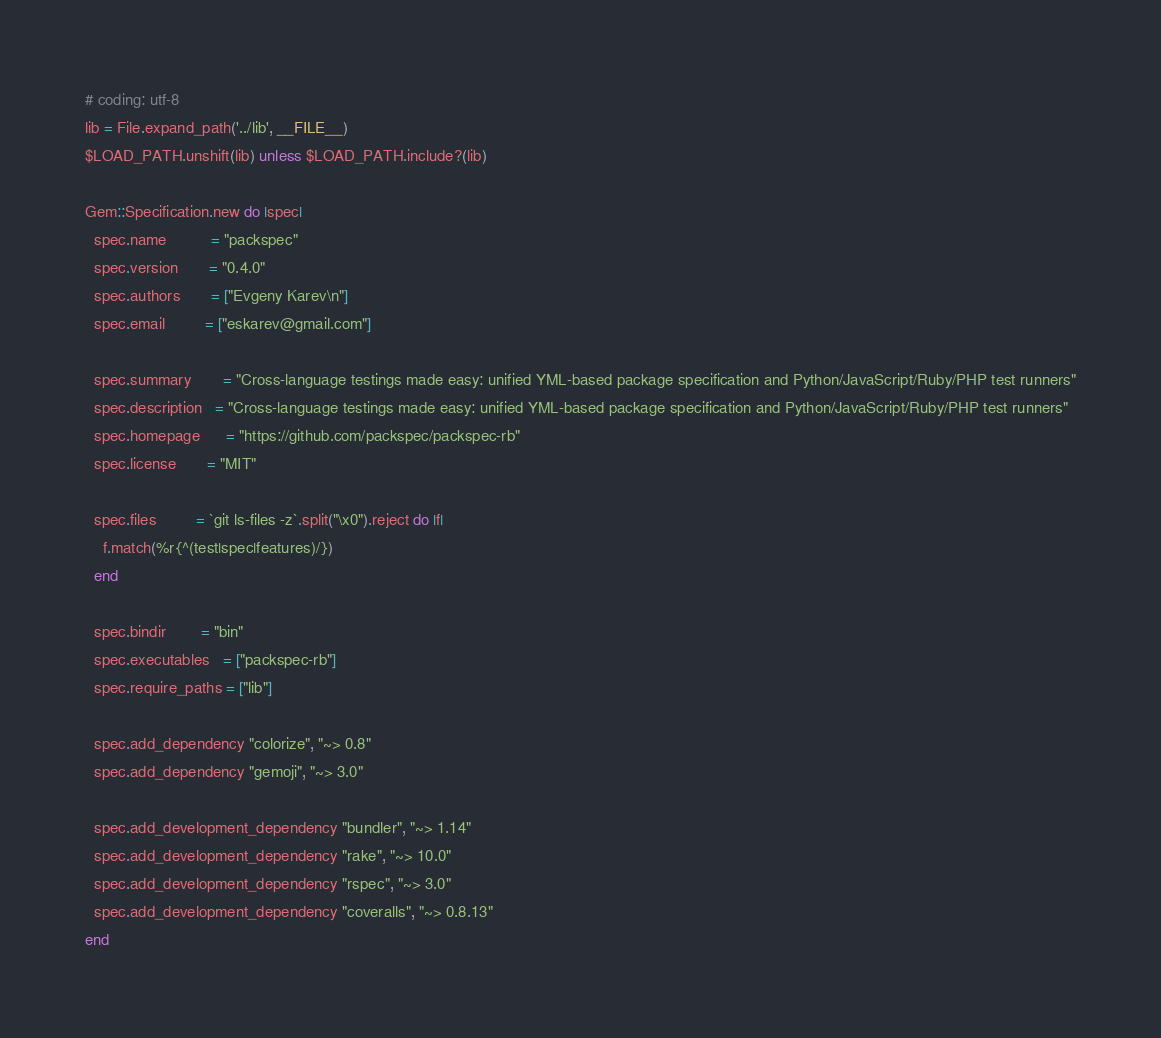<code> <loc_0><loc_0><loc_500><loc_500><_Ruby_># coding: utf-8
lib = File.expand_path('../lib', __FILE__)
$LOAD_PATH.unshift(lib) unless $LOAD_PATH.include?(lib)

Gem::Specification.new do |spec|
  spec.name          = "packspec"
  spec.version       = "0.4.0"
  spec.authors       = ["Evgeny Karev\n"]
  spec.email         = ["eskarev@gmail.com"]

  spec.summary       = "Cross-language testings made easy: unified YML-based package specification and Python/JavaScript/Ruby/PHP test runners"
  spec.description   = "Cross-language testings made easy: unified YML-based package specification and Python/JavaScript/Ruby/PHP test runners"
  spec.homepage      = "https://github.com/packspec/packspec-rb"
  spec.license       = "MIT"

  spec.files         = `git ls-files -z`.split("\x0").reject do |f|
    f.match(%r{^(test|spec|features)/})
  end

  spec.bindir        = "bin"
  spec.executables   = ["packspec-rb"]
  spec.require_paths = ["lib"]

  spec.add_dependency "colorize", "~> 0.8"
  spec.add_dependency "gemoji", "~> 3.0"

  spec.add_development_dependency "bundler", "~> 1.14"
  spec.add_development_dependency "rake", "~> 10.0"
  spec.add_development_dependency "rspec", "~> 3.0"
  spec.add_development_dependency "coveralls", "~> 0.8.13"
end
</code> 